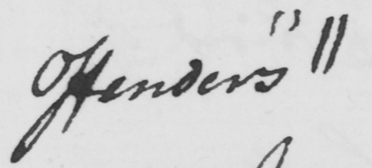What text is written in this handwritten line? offenders "  || 